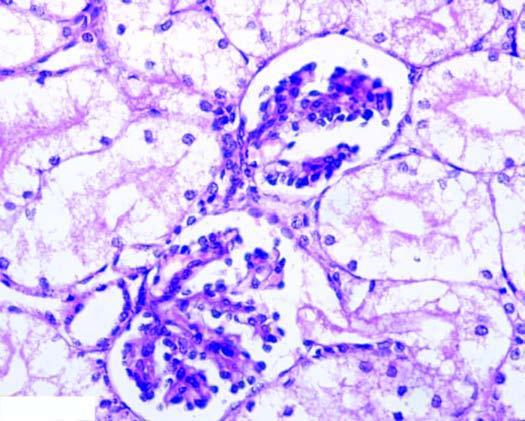what are distended with cytoplasmic vacuoles while the interstitial vasculature is compressed?
Answer the question using a single word or phrase. Tubular epithelial cells 